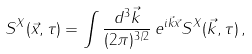Convert formula to latex. <formula><loc_0><loc_0><loc_500><loc_500>S ^ { X } ( \vec { x } , \tau ) = \int \frac { d ^ { 3 } \vec { k } } { ( 2 \pi ) ^ { 3 / 2 } } \, e ^ { i \vec { k } \vec { x } } S ^ { X } ( \vec { k } , \tau ) \, ,</formula> 